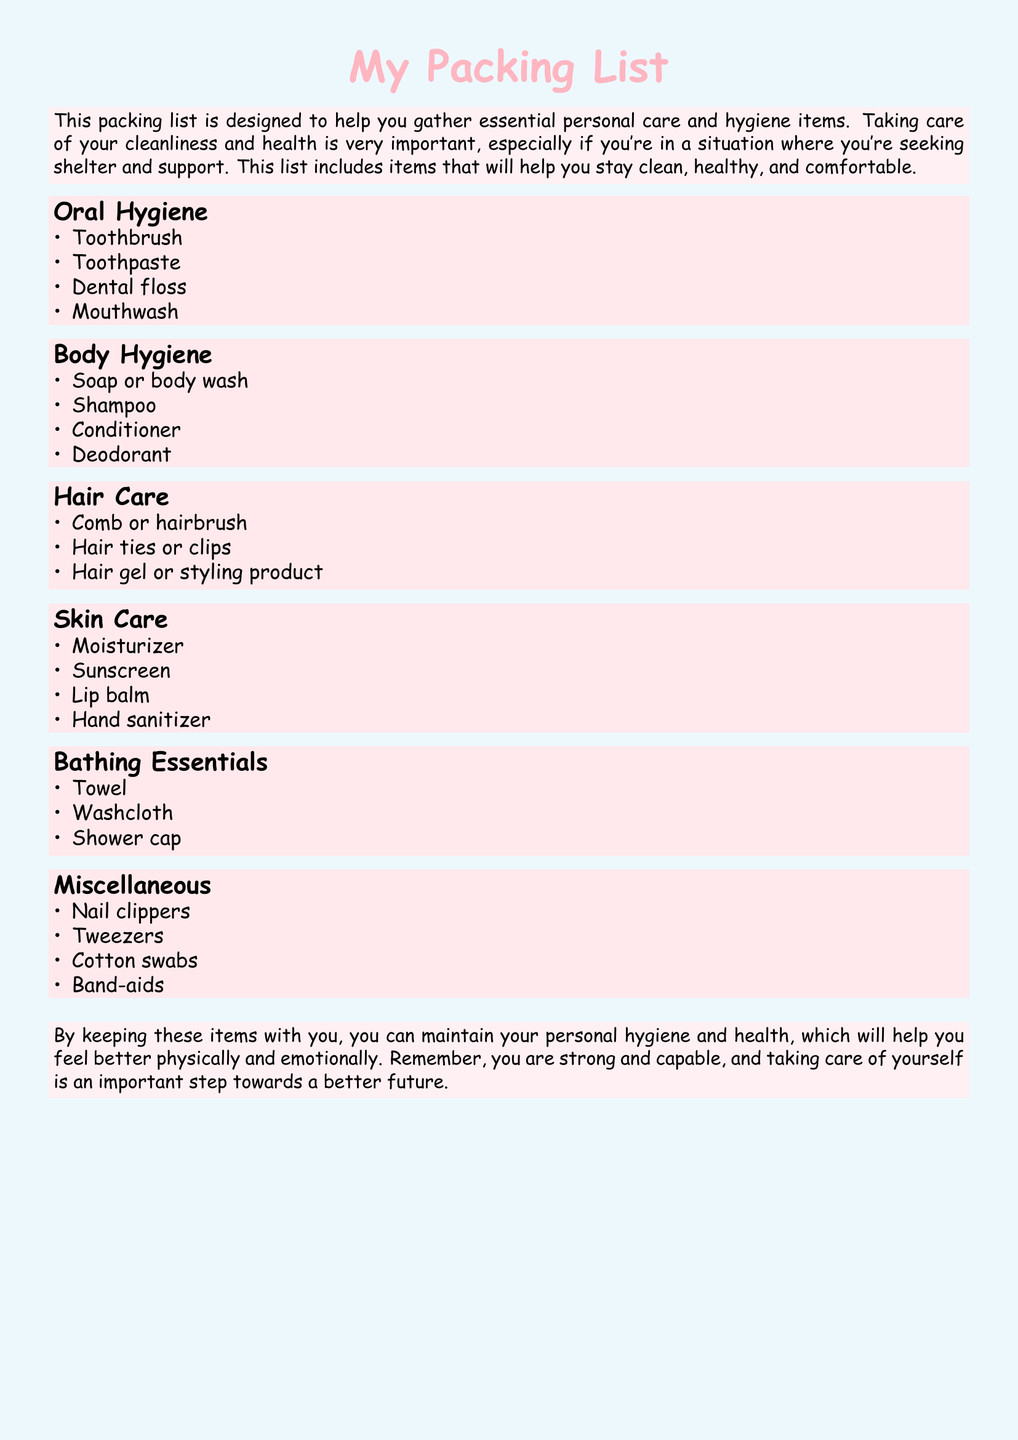What are the items listed under Oral Hygiene? The document provides a list of items specifically categorized under Oral Hygiene.
Answer: Toothbrush, Toothpaste, Dental floss, Mouthwash How many categories are in the packing list? The document includes different categories of personal care items.
Answer: 6 What is one item included in the Body Hygiene category? The document lists specific items under the Body Hygiene category.
Answer: Soap or body wash What are the Bathing Essentials mentioned? The document details the essential items needed for bathing under a specific category.
Answer: Towel, Washcloth, Shower cap What additional skin care item is included besides moisturizer? The document specifies items included in the Skin Care category.
Answer: Sunscreen Which personal care item helps with nail grooming? The document identifies various miscellaneous items related to personal care.
Answer: Nail clippers 